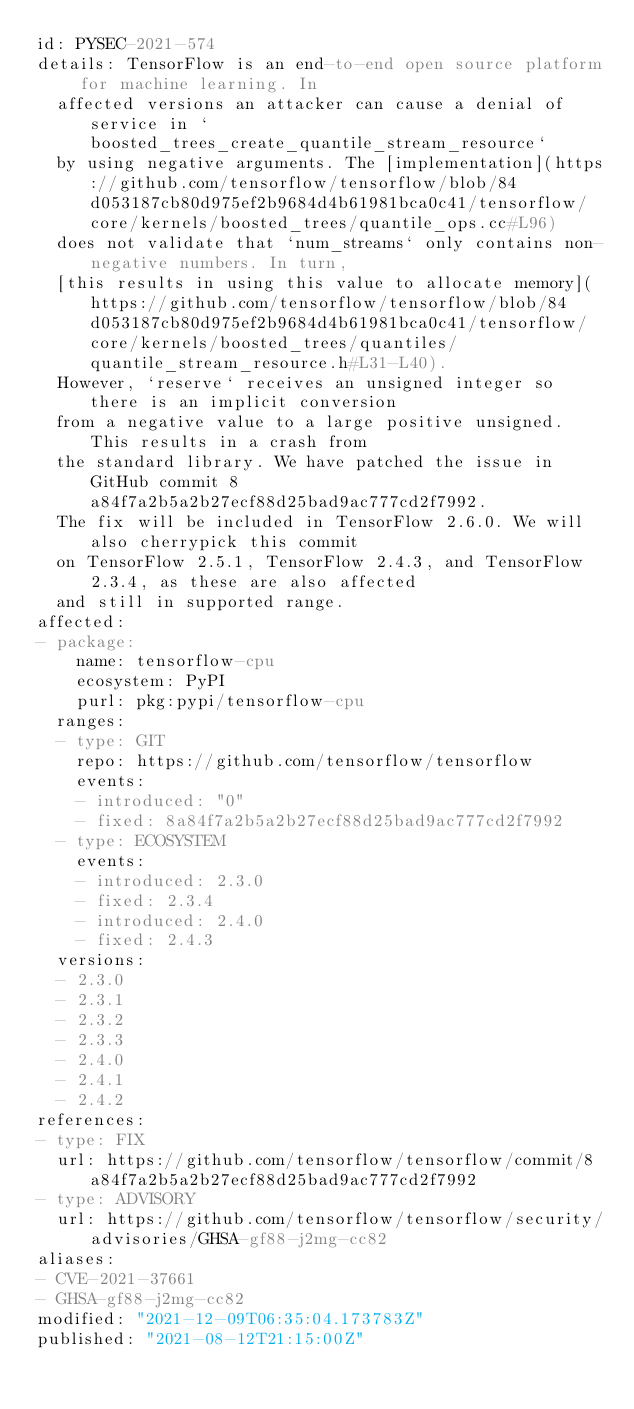<code> <loc_0><loc_0><loc_500><loc_500><_YAML_>id: PYSEC-2021-574
details: TensorFlow is an end-to-end open source platform for machine learning. In
  affected versions an attacker can cause a denial of service in `boosted_trees_create_quantile_stream_resource`
  by using negative arguments. The [implementation](https://github.com/tensorflow/tensorflow/blob/84d053187cb80d975ef2b9684d4b61981bca0c41/tensorflow/core/kernels/boosted_trees/quantile_ops.cc#L96)
  does not validate that `num_streams` only contains non-negative numbers. In turn,
  [this results in using this value to allocate memory](https://github.com/tensorflow/tensorflow/blob/84d053187cb80d975ef2b9684d4b61981bca0c41/tensorflow/core/kernels/boosted_trees/quantiles/quantile_stream_resource.h#L31-L40).
  However, `reserve` receives an unsigned integer so there is an implicit conversion
  from a negative value to a large positive unsigned. This results in a crash from
  the standard library. We have patched the issue in GitHub commit 8a84f7a2b5a2b27ecf88d25bad9ac777cd2f7992.
  The fix will be included in TensorFlow 2.6.0. We will also cherrypick this commit
  on TensorFlow 2.5.1, TensorFlow 2.4.3, and TensorFlow 2.3.4, as these are also affected
  and still in supported range.
affected:
- package:
    name: tensorflow-cpu
    ecosystem: PyPI
    purl: pkg:pypi/tensorflow-cpu
  ranges:
  - type: GIT
    repo: https://github.com/tensorflow/tensorflow
    events:
    - introduced: "0"
    - fixed: 8a84f7a2b5a2b27ecf88d25bad9ac777cd2f7992
  - type: ECOSYSTEM
    events:
    - introduced: 2.3.0
    - fixed: 2.3.4
    - introduced: 2.4.0
    - fixed: 2.4.3
  versions:
  - 2.3.0
  - 2.3.1
  - 2.3.2
  - 2.3.3
  - 2.4.0
  - 2.4.1
  - 2.4.2
references:
- type: FIX
  url: https://github.com/tensorflow/tensorflow/commit/8a84f7a2b5a2b27ecf88d25bad9ac777cd2f7992
- type: ADVISORY
  url: https://github.com/tensorflow/tensorflow/security/advisories/GHSA-gf88-j2mg-cc82
aliases:
- CVE-2021-37661
- GHSA-gf88-j2mg-cc82
modified: "2021-12-09T06:35:04.173783Z"
published: "2021-08-12T21:15:00Z"
</code> 